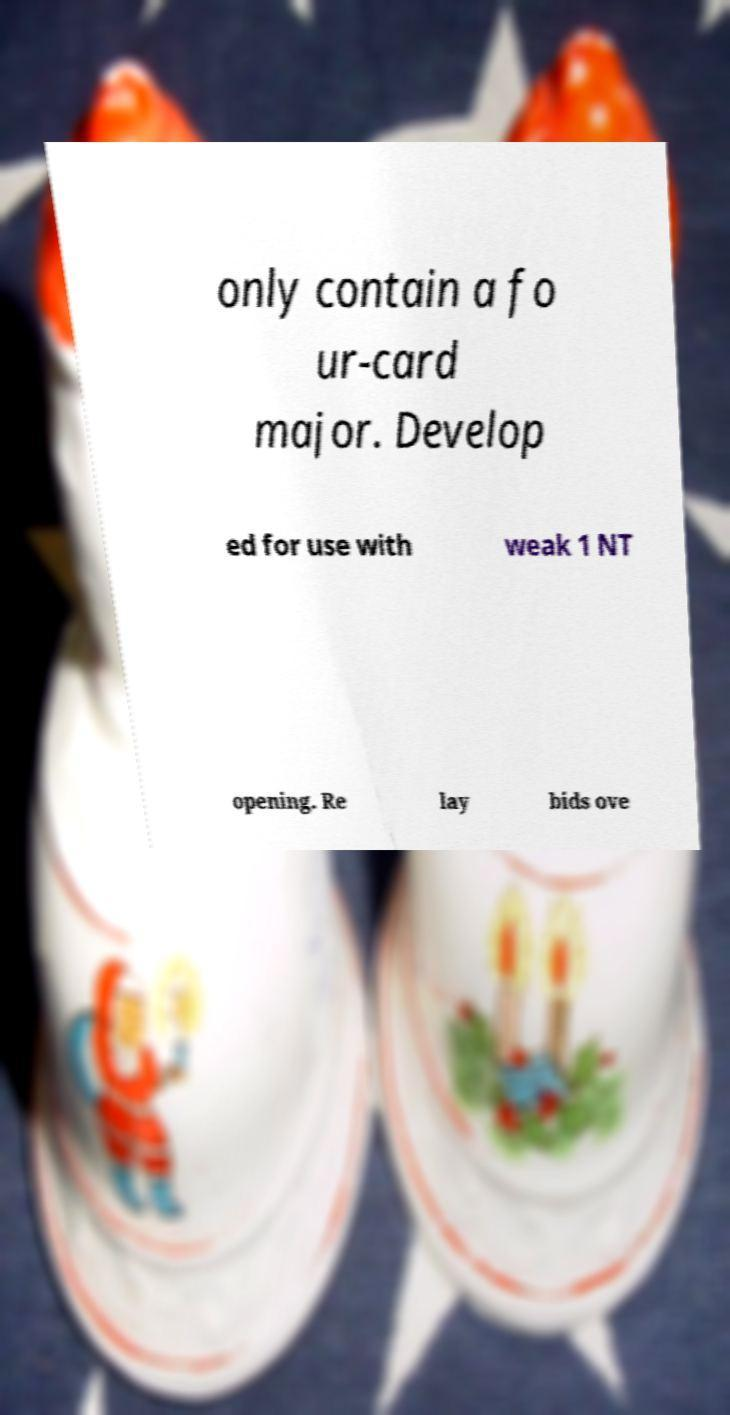Could you extract and type out the text from this image? only contain a fo ur-card major. Develop ed for use with weak 1 NT opening. Re lay bids ove 